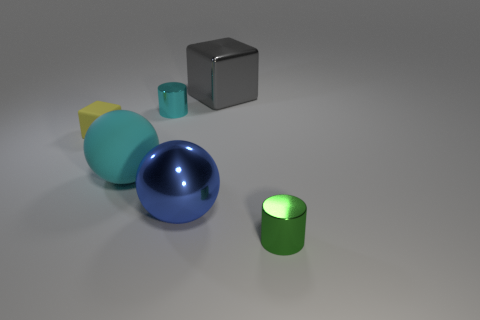Are there fewer tiny objects to the right of the tiny yellow matte object than objects behind the big blue metallic sphere?
Make the answer very short. Yes. Is there anything else that is the same color as the rubber block?
Ensure brevity in your answer.  No. The big cyan thing has what shape?
Make the answer very short. Sphere. What is the color of the block that is the same material as the big blue thing?
Provide a short and direct response. Gray. Are there more large gray blocks than large things?
Offer a very short reply. No. Is there a large purple rubber block?
Your answer should be very brief. No. The big blue thing behind the small object that is in front of the large cyan thing is what shape?
Make the answer very short. Sphere. What number of things are small rubber blocks or small shiny things that are in front of the small matte thing?
Your answer should be very brief. 2. The large metal object left of the big object behind the cyan thing that is behind the tiny matte cube is what color?
Your answer should be compact. Blue. There is a tiny green object that is the same shape as the cyan metallic thing; what is it made of?
Provide a succinct answer. Metal. 